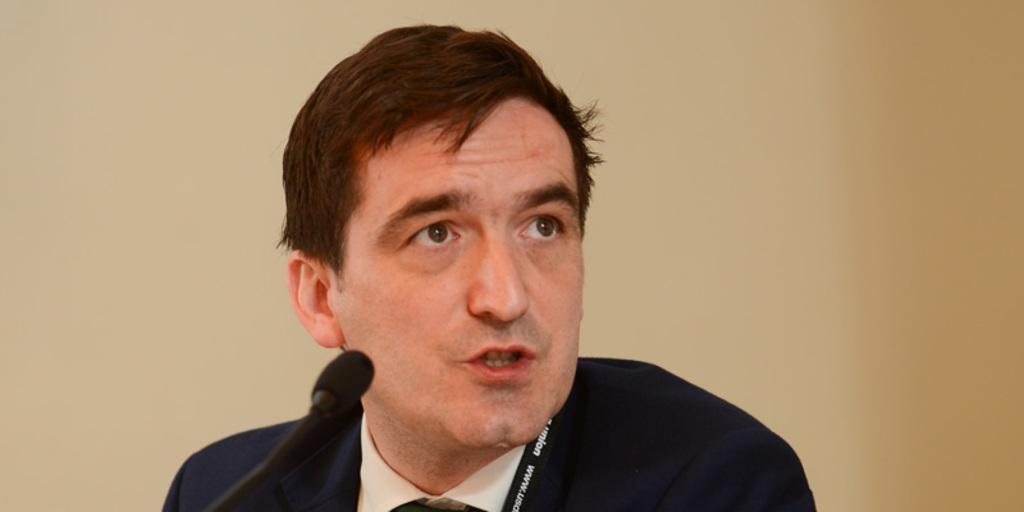What is located in the front of the image? There is a mic in the front of the image. What is the person doing with the mic? There is a person speaking on the mic. What type of fear can be seen in the wilderness in the image? There is no fear or wilderness present in the image; it features a mic and a person speaking on it. Can you spot any frogs in the image? There are no frogs present in the image. 